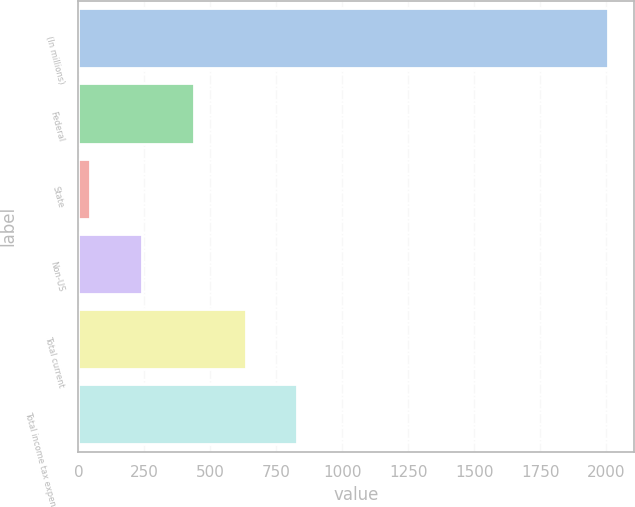Convert chart. <chart><loc_0><loc_0><loc_500><loc_500><bar_chart><fcel>(In millions)<fcel>Federal<fcel>State<fcel>Non-US<fcel>Total current<fcel>Total income tax expense from<nl><fcel>2005<fcel>437.8<fcel>46<fcel>241.9<fcel>633.7<fcel>829.6<nl></chart> 